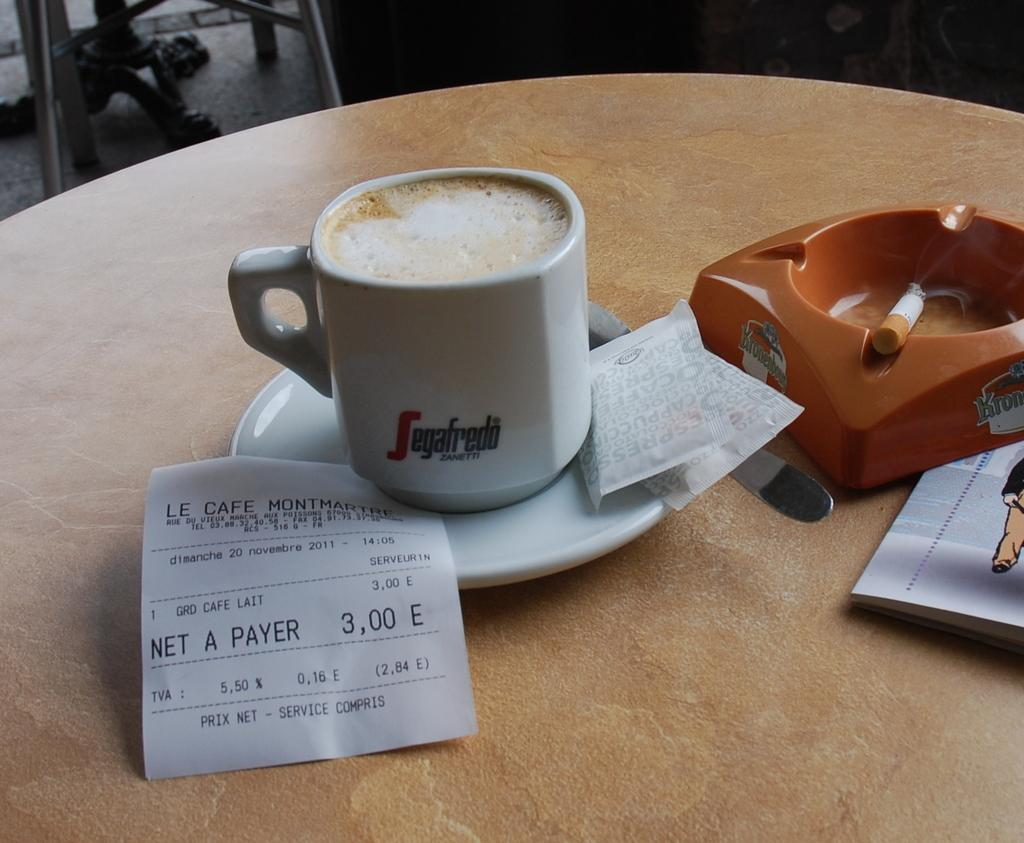<image>
Give a short and clear explanation of the subsequent image. a cup of Segafredo Zanetti espresso on a table next to an ashtray 